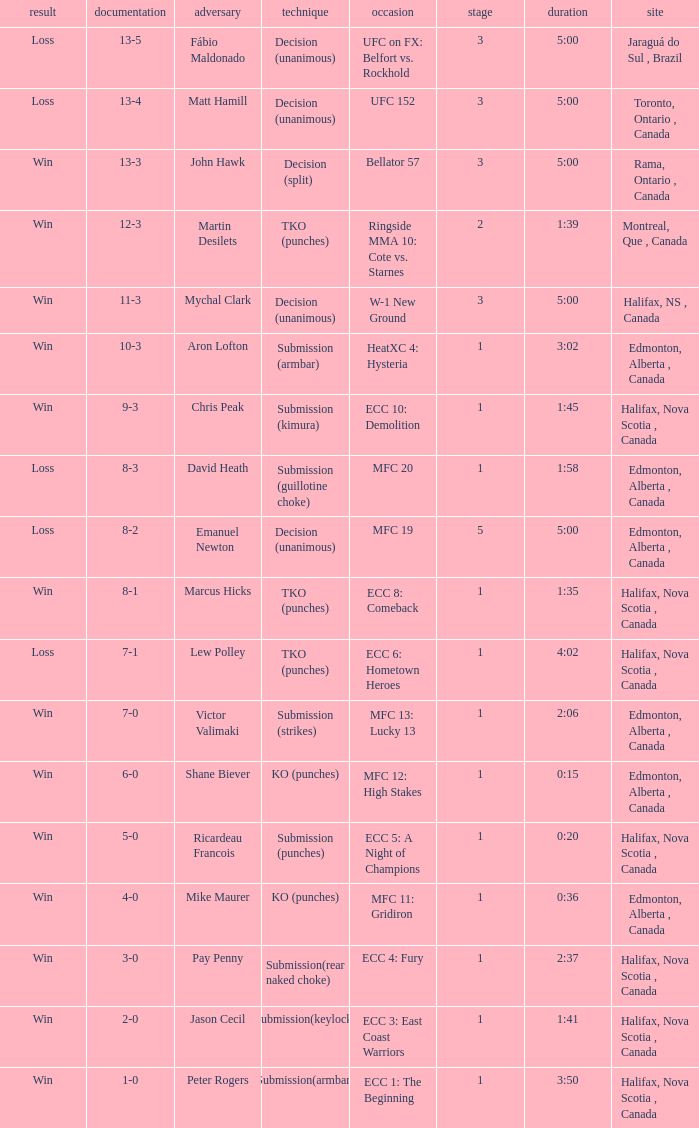Who is the opponent of the match with a win result and a time of 3:02? Aron Lofton. 